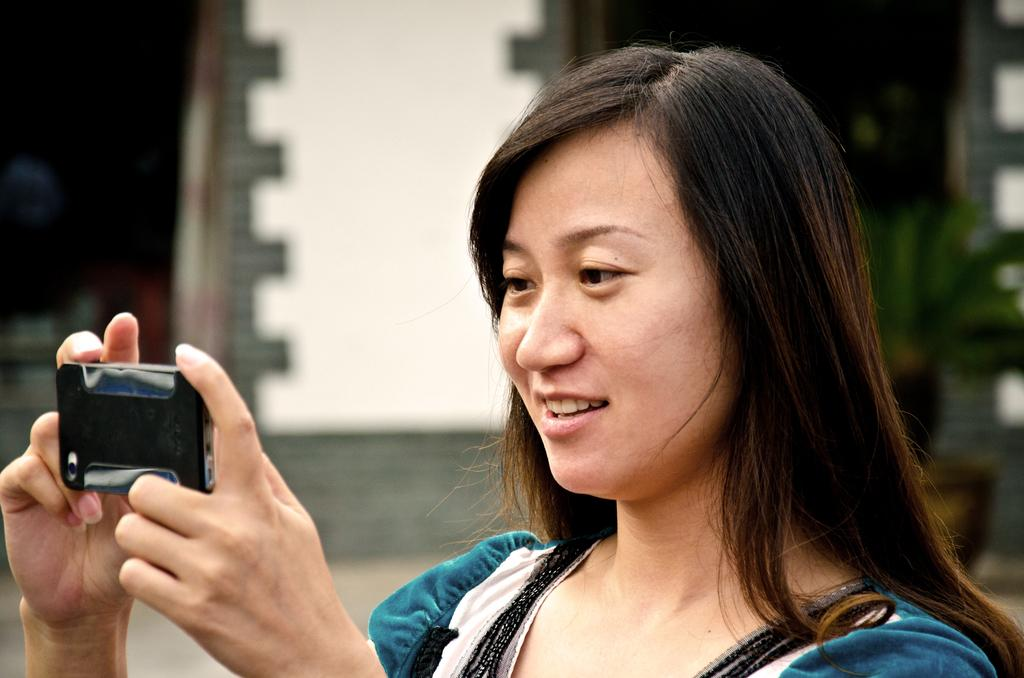Who is present in the image? There is a woman in the image. What is the woman doing in the image? The woman is smiling in the image. What is the woman holding in her hands? The woman is holding a mobile in her hands. What type of government is depicted in the image? There is no depiction of a government in the image; it features a woman smiling and holding a mobile. What type of writing instrument is the woman using in the image? The woman is not using any writing instrument in the image; she is holding a mobile. 